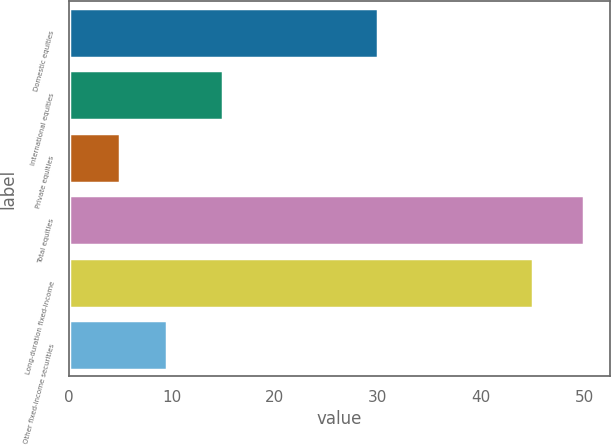Convert chart to OTSL. <chart><loc_0><loc_0><loc_500><loc_500><bar_chart><fcel>Domestic equities<fcel>International equities<fcel>Private equities<fcel>Total equities<fcel>Long-duration fixed-income<fcel>Other fixed-income securities<nl><fcel>30<fcel>15<fcel>5<fcel>50<fcel>45<fcel>9.5<nl></chart> 